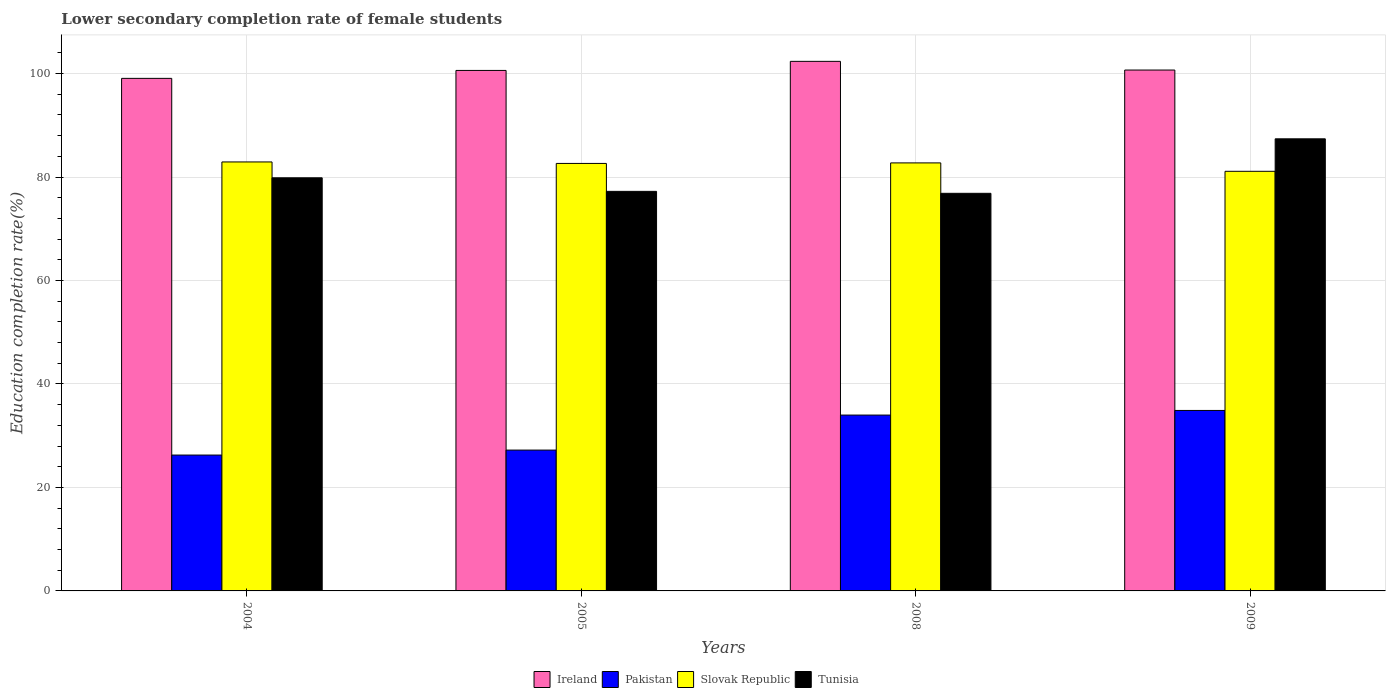How many groups of bars are there?
Offer a terse response. 4. Are the number of bars on each tick of the X-axis equal?
Provide a succinct answer. Yes. How many bars are there on the 1st tick from the left?
Offer a very short reply. 4. What is the lower secondary completion rate of female students in Slovak Republic in 2004?
Offer a very short reply. 82.92. Across all years, what is the maximum lower secondary completion rate of female students in Pakistan?
Ensure brevity in your answer.  34.88. Across all years, what is the minimum lower secondary completion rate of female students in Ireland?
Keep it short and to the point. 99.07. What is the total lower secondary completion rate of female students in Ireland in the graph?
Ensure brevity in your answer.  402.71. What is the difference between the lower secondary completion rate of female students in Ireland in 2005 and that in 2008?
Give a very brief answer. -1.76. What is the difference between the lower secondary completion rate of female students in Tunisia in 2005 and the lower secondary completion rate of female students in Ireland in 2004?
Provide a succinct answer. -21.84. What is the average lower secondary completion rate of female students in Slovak Republic per year?
Provide a succinct answer. 82.35. In the year 2004, what is the difference between the lower secondary completion rate of female students in Slovak Republic and lower secondary completion rate of female students in Pakistan?
Your answer should be compact. 56.66. What is the ratio of the lower secondary completion rate of female students in Ireland in 2005 to that in 2008?
Provide a short and direct response. 0.98. Is the lower secondary completion rate of female students in Slovak Republic in 2004 less than that in 2005?
Provide a short and direct response. No. What is the difference between the highest and the second highest lower secondary completion rate of female students in Ireland?
Provide a short and direct response. 1.68. What is the difference between the highest and the lowest lower secondary completion rate of female students in Slovak Republic?
Your answer should be very brief. 1.81. In how many years, is the lower secondary completion rate of female students in Ireland greater than the average lower secondary completion rate of female students in Ireland taken over all years?
Provide a succinct answer. 2. Is it the case that in every year, the sum of the lower secondary completion rate of female students in Slovak Republic and lower secondary completion rate of female students in Ireland is greater than the sum of lower secondary completion rate of female students in Pakistan and lower secondary completion rate of female students in Tunisia?
Make the answer very short. Yes. What does the 4th bar from the left in 2009 represents?
Your answer should be compact. Tunisia. What does the 2nd bar from the right in 2008 represents?
Give a very brief answer. Slovak Republic. How many bars are there?
Provide a succinct answer. 16. How many years are there in the graph?
Provide a succinct answer. 4. What is the difference between two consecutive major ticks on the Y-axis?
Offer a terse response. 20. Does the graph contain any zero values?
Your response must be concise. No. Does the graph contain grids?
Provide a short and direct response. Yes. How many legend labels are there?
Your answer should be very brief. 4. How are the legend labels stacked?
Your answer should be very brief. Horizontal. What is the title of the graph?
Make the answer very short. Lower secondary completion rate of female students. What is the label or title of the Y-axis?
Offer a terse response. Education completion rate(%). What is the Education completion rate(%) of Ireland in 2004?
Your response must be concise. 99.07. What is the Education completion rate(%) of Pakistan in 2004?
Give a very brief answer. 26.26. What is the Education completion rate(%) in Slovak Republic in 2004?
Provide a short and direct response. 82.92. What is the Education completion rate(%) in Tunisia in 2004?
Offer a terse response. 79.85. What is the Education completion rate(%) in Ireland in 2005?
Provide a short and direct response. 100.6. What is the Education completion rate(%) of Pakistan in 2005?
Keep it short and to the point. 27.22. What is the Education completion rate(%) in Slovak Republic in 2005?
Provide a short and direct response. 82.63. What is the Education completion rate(%) in Tunisia in 2005?
Make the answer very short. 77.23. What is the Education completion rate(%) in Ireland in 2008?
Your response must be concise. 102.36. What is the Education completion rate(%) of Pakistan in 2008?
Provide a succinct answer. 33.99. What is the Education completion rate(%) in Slovak Republic in 2008?
Your answer should be compact. 82.73. What is the Education completion rate(%) in Tunisia in 2008?
Your response must be concise. 76.85. What is the Education completion rate(%) of Ireland in 2009?
Offer a very short reply. 100.68. What is the Education completion rate(%) of Pakistan in 2009?
Offer a very short reply. 34.88. What is the Education completion rate(%) of Slovak Republic in 2009?
Give a very brief answer. 81.11. What is the Education completion rate(%) of Tunisia in 2009?
Give a very brief answer. 87.39. Across all years, what is the maximum Education completion rate(%) in Ireland?
Make the answer very short. 102.36. Across all years, what is the maximum Education completion rate(%) in Pakistan?
Offer a terse response. 34.88. Across all years, what is the maximum Education completion rate(%) of Slovak Republic?
Provide a short and direct response. 82.92. Across all years, what is the maximum Education completion rate(%) in Tunisia?
Make the answer very short. 87.39. Across all years, what is the minimum Education completion rate(%) in Ireland?
Offer a very short reply. 99.07. Across all years, what is the minimum Education completion rate(%) of Pakistan?
Give a very brief answer. 26.26. Across all years, what is the minimum Education completion rate(%) in Slovak Republic?
Keep it short and to the point. 81.11. Across all years, what is the minimum Education completion rate(%) of Tunisia?
Offer a terse response. 76.85. What is the total Education completion rate(%) in Ireland in the graph?
Give a very brief answer. 402.71. What is the total Education completion rate(%) of Pakistan in the graph?
Provide a short and direct response. 122.35. What is the total Education completion rate(%) of Slovak Republic in the graph?
Your answer should be very brief. 329.38. What is the total Education completion rate(%) in Tunisia in the graph?
Offer a terse response. 321.32. What is the difference between the Education completion rate(%) in Ireland in 2004 and that in 2005?
Make the answer very short. -1.53. What is the difference between the Education completion rate(%) of Pakistan in 2004 and that in 2005?
Provide a short and direct response. -0.96. What is the difference between the Education completion rate(%) of Slovak Republic in 2004 and that in 2005?
Offer a terse response. 0.29. What is the difference between the Education completion rate(%) in Tunisia in 2004 and that in 2005?
Your response must be concise. 2.62. What is the difference between the Education completion rate(%) in Ireland in 2004 and that in 2008?
Your answer should be compact. -3.29. What is the difference between the Education completion rate(%) in Pakistan in 2004 and that in 2008?
Offer a very short reply. -7.73. What is the difference between the Education completion rate(%) of Slovak Republic in 2004 and that in 2008?
Provide a short and direct response. 0.19. What is the difference between the Education completion rate(%) of Tunisia in 2004 and that in 2008?
Make the answer very short. 3. What is the difference between the Education completion rate(%) of Ireland in 2004 and that in 2009?
Provide a succinct answer. -1.61. What is the difference between the Education completion rate(%) of Pakistan in 2004 and that in 2009?
Your response must be concise. -8.62. What is the difference between the Education completion rate(%) of Slovak Republic in 2004 and that in 2009?
Offer a very short reply. 1.81. What is the difference between the Education completion rate(%) of Tunisia in 2004 and that in 2009?
Your response must be concise. -7.54. What is the difference between the Education completion rate(%) in Ireland in 2005 and that in 2008?
Offer a terse response. -1.76. What is the difference between the Education completion rate(%) of Pakistan in 2005 and that in 2008?
Provide a short and direct response. -6.77. What is the difference between the Education completion rate(%) in Slovak Republic in 2005 and that in 2008?
Provide a succinct answer. -0.1. What is the difference between the Education completion rate(%) of Tunisia in 2005 and that in 2008?
Offer a very short reply. 0.38. What is the difference between the Education completion rate(%) in Ireland in 2005 and that in 2009?
Your response must be concise. -0.08. What is the difference between the Education completion rate(%) of Pakistan in 2005 and that in 2009?
Keep it short and to the point. -7.66. What is the difference between the Education completion rate(%) in Slovak Republic in 2005 and that in 2009?
Provide a short and direct response. 1.52. What is the difference between the Education completion rate(%) in Tunisia in 2005 and that in 2009?
Give a very brief answer. -10.16. What is the difference between the Education completion rate(%) of Ireland in 2008 and that in 2009?
Give a very brief answer. 1.68. What is the difference between the Education completion rate(%) in Pakistan in 2008 and that in 2009?
Your response must be concise. -0.9. What is the difference between the Education completion rate(%) of Slovak Republic in 2008 and that in 2009?
Offer a terse response. 1.62. What is the difference between the Education completion rate(%) of Tunisia in 2008 and that in 2009?
Provide a succinct answer. -10.53. What is the difference between the Education completion rate(%) of Ireland in 2004 and the Education completion rate(%) of Pakistan in 2005?
Keep it short and to the point. 71.85. What is the difference between the Education completion rate(%) of Ireland in 2004 and the Education completion rate(%) of Slovak Republic in 2005?
Offer a terse response. 16.44. What is the difference between the Education completion rate(%) of Ireland in 2004 and the Education completion rate(%) of Tunisia in 2005?
Provide a succinct answer. 21.84. What is the difference between the Education completion rate(%) of Pakistan in 2004 and the Education completion rate(%) of Slovak Republic in 2005?
Ensure brevity in your answer.  -56.37. What is the difference between the Education completion rate(%) of Pakistan in 2004 and the Education completion rate(%) of Tunisia in 2005?
Offer a very short reply. -50.97. What is the difference between the Education completion rate(%) in Slovak Republic in 2004 and the Education completion rate(%) in Tunisia in 2005?
Your answer should be compact. 5.69. What is the difference between the Education completion rate(%) of Ireland in 2004 and the Education completion rate(%) of Pakistan in 2008?
Keep it short and to the point. 65.08. What is the difference between the Education completion rate(%) of Ireland in 2004 and the Education completion rate(%) of Slovak Republic in 2008?
Provide a short and direct response. 16.34. What is the difference between the Education completion rate(%) of Ireland in 2004 and the Education completion rate(%) of Tunisia in 2008?
Offer a terse response. 22.22. What is the difference between the Education completion rate(%) in Pakistan in 2004 and the Education completion rate(%) in Slovak Republic in 2008?
Offer a very short reply. -56.47. What is the difference between the Education completion rate(%) in Pakistan in 2004 and the Education completion rate(%) in Tunisia in 2008?
Provide a succinct answer. -50.59. What is the difference between the Education completion rate(%) of Slovak Republic in 2004 and the Education completion rate(%) of Tunisia in 2008?
Make the answer very short. 6.06. What is the difference between the Education completion rate(%) in Ireland in 2004 and the Education completion rate(%) in Pakistan in 2009?
Keep it short and to the point. 64.19. What is the difference between the Education completion rate(%) of Ireland in 2004 and the Education completion rate(%) of Slovak Republic in 2009?
Provide a succinct answer. 17.96. What is the difference between the Education completion rate(%) in Ireland in 2004 and the Education completion rate(%) in Tunisia in 2009?
Keep it short and to the point. 11.69. What is the difference between the Education completion rate(%) in Pakistan in 2004 and the Education completion rate(%) in Slovak Republic in 2009?
Make the answer very short. -54.85. What is the difference between the Education completion rate(%) in Pakistan in 2004 and the Education completion rate(%) in Tunisia in 2009?
Offer a terse response. -61.13. What is the difference between the Education completion rate(%) of Slovak Republic in 2004 and the Education completion rate(%) of Tunisia in 2009?
Ensure brevity in your answer.  -4.47. What is the difference between the Education completion rate(%) of Ireland in 2005 and the Education completion rate(%) of Pakistan in 2008?
Give a very brief answer. 66.61. What is the difference between the Education completion rate(%) of Ireland in 2005 and the Education completion rate(%) of Slovak Republic in 2008?
Keep it short and to the point. 17.87. What is the difference between the Education completion rate(%) in Ireland in 2005 and the Education completion rate(%) in Tunisia in 2008?
Make the answer very short. 23.75. What is the difference between the Education completion rate(%) in Pakistan in 2005 and the Education completion rate(%) in Slovak Republic in 2008?
Provide a short and direct response. -55.51. What is the difference between the Education completion rate(%) of Pakistan in 2005 and the Education completion rate(%) of Tunisia in 2008?
Ensure brevity in your answer.  -49.63. What is the difference between the Education completion rate(%) in Slovak Republic in 2005 and the Education completion rate(%) in Tunisia in 2008?
Provide a succinct answer. 5.78. What is the difference between the Education completion rate(%) in Ireland in 2005 and the Education completion rate(%) in Pakistan in 2009?
Your answer should be compact. 65.72. What is the difference between the Education completion rate(%) of Ireland in 2005 and the Education completion rate(%) of Slovak Republic in 2009?
Give a very brief answer. 19.5. What is the difference between the Education completion rate(%) of Ireland in 2005 and the Education completion rate(%) of Tunisia in 2009?
Your answer should be compact. 13.22. What is the difference between the Education completion rate(%) in Pakistan in 2005 and the Education completion rate(%) in Slovak Republic in 2009?
Your answer should be compact. -53.89. What is the difference between the Education completion rate(%) in Pakistan in 2005 and the Education completion rate(%) in Tunisia in 2009?
Offer a terse response. -60.16. What is the difference between the Education completion rate(%) in Slovak Republic in 2005 and the Education completion rate(%) in Tunisia in 2009?
Offer a very short reply. -4.76. What is the difference between the Education completion rate(%) of Ireland in 2008 and the Education completion rate(%) of Pakistan in 2009?
Make the answer very short. 67.47. What is the difference between the Education completion rate(%) of Ireland in 2008 and the Education completion rate(%) of Slovak Republic in 2009?
Offer a very short reply. 21.25. What is the difference between the Education completion rate(%) of Ireland in 2008 and the Education completion rate(%) of Tunisia in 2009?
Offer a terse response. 14.97. What is the difference between the Education completion rate(%) of Pakistan in 2008 and the Education completion rate(%) of Slovak Republic in 2009?
Give a very brief answer. -47.12. What is the difference between the Education completion rate(%) in Pakistan in 2008 and the Education completion rate(%) in Tunisia in 2009?
Keep it short and to the point. -53.4. What is the difference between the Education completion rate(%) in Slovak Republic in 2008 and the Education completion rate(%) in Tunisia in 2009?
Give a very brief answer. -4.66. What is the average Education completion rate(%) in Ireland per year?
Provide a succinct answer. 100.68. What is the average Education completion rate(%) of Pakistan per year?
Offer a terse response. 30.59. What is the average Education completion rate(%) of Slovak Republic per year?
Your answer should be compact. 82.35. What is the average Education completion rate(%) in Tunisia per year?
Offer a very short reply. 80.33. In the year 2004, what is the difference between the Education completion rate(%) of Ireland and Education completion rate(%) of Pakistan?
Provide a succinct answer. 72.81. In the year 2004, what is the difference between the Education completion rate(%) of Ireland and Education completion rate(%) of Slovak Republic?
Offer a very short reply. 16.16. In the year 2004, what is the difference between the Education completion rate(%) of Ireland and Education completion rate(%) of Tunisia?
Your answer should be compact. 19.22. In the year 2004, what is the difference between the Education completion rate(%) of Pakistan and Education completion rate(%) of Slovak Republic?
Make the answer very short. -56.66. In the year 2004, what is the difference between the Education completion rate(%) in Pakistan and Education completion rate(%) in Tunisia?
Your response must be concise. -53.59. In the year 2004, what is the difference between the Education completion rate(%) of Slovak Republic and Education completion rate(%) of Tunisia?
Offer a very short reply. 3.07. In the year 2005, what is the difference between the Education completion rate(%) of Ireland and Education completion rate(%) of Pakistan?
Keep it short and to the point. 73.38. In the year 2005, what is the difference between the Education completion rate(%) of Ireland and Education completion rate(%) of Slovak Republic?
Offer a terse response. 17.98. In the year 2005, what is the difference between the Education completion rate(%) in Ireland and Education completion rate(%) in Tunisia?
Your response must be concise. 23.37. In the year 2005, what is the difference between the Education completion rate(%) of Pakistan and Education completion rate(%) of Slovak Republic?
Keep it short and to the point. -55.41. In the year 2005, what is the difference between the Education completion rate(%) in Pakistan and Education completion rate(%) in Tunisia?
Your answer should be compact. -50.01. In the year 2005, what is the difference between the Education completion rate(%) in Slovak Republic and Education completion rate(%) in Tunisia?
Offer a very short reply. 5.4. In the year 2008, what is the difference between the Education completion rate(%) of Ireland and Education completion rate(%) of Pakistan?
Your response must be concise. 68.37. In the year 2008, what is the difference between the Education completion rate(%) in Ireland and Education completion rate(%) in Slovak Republic?
Offer a terse response. 19.63. In the year 2008, what is the difference between the Education completion rate(%) in Ireland and Education completion rate(%) in Tunisia?
Offer a terse response. 25.51. In the year 2008, what is the difference between the Education completion rate(%) in Pakistan and Education completion rate(%) in Slovak Republic?
Give a very brief answer. -48.74. In the year 2008, what is the difference between the Education completion rate(%) in Pakistan and Education completion rate(%) in Tunisia?
Offer a very short reply. -42.86. In the year 2008, what is the difference between the Education completion rate(%) in Slovak Republic and Education completion rate(%) in Tunisia?
Keep it short and to the point. 5.88. In the year 2009, what is the difference between the Education completion rate(%) of Ireland and Education completion rate(%) of Pakistan?
Offer a terse response. 65.8. In the year 2009, what is the difference between the Education completion rate(%) of Ireland and Education completion rate(%) of Slovak Republic?
Offer a very short reply. 19.57. In the year 2009, what is the difference between the Education completion rate(%) of Ireland and Education completion rate(%) of Tunisia?
Provide a succinct answer. 13.29. In the year 2009, what is the difference between the Education completion rate(%) of Pakistan and Education completion rate(%) of Slovak Republic?
Offer a terse response. -46.22. In the year 2009, what is the difference between the Education completion rate(%) of Pakistan and Education completion rate(%) of Tunisia?
Give a very brief answer. -52.5. In the year 2009, what is the difference between the Education completion rate(%) of Slovak Republic and Education completion rate(%) of Tunisia?
Offer a very short reply. -6.28. What is the ratio of the Education completion rate(%) of Ireland in 2004 to that in 2005?
Ensure brevity in your answer.  0.98. What is the ratio of the Education completion rate(%) in Pakistan in 2004 to that in 2005?
Keep it short and to the point. 0.96. What is the ratio of the Education completion rate(%) in Slovak Republic in 2004 to that in 2005?
Provide a succinct answer. 1. What is the ratio of the Education completion rate(%) in Tunisia in 2004 to that in 2005?
Make the answer very short. 1.03. What is the ratio of the Education completion rate(%) of Ireland in 2004 to that in 2008?
Give a very brief answer. 0.97. What is the ratio of the Education completion rate(%) of Pakistan in 2004 to that in 2008?
Offer a very short reply. 0.77. What is the ratio of the Education completion rate(%) of Tunisia in 2004 to that in 2008?
Keep it short and to the point. 1.04. What is the ratio of the Education completion rate(%) of Pakistan in 2004 to that in 2009?
Give a very brief answer. 0.75. What is the ratio of the Education completion rate(%) in Slovak Republic in 2004 to that in 2009?
Provide a short and direct response. 1.02. What is the ratio of the Education completion rate(%) in Tunisia in 2004 to that in 2009?
Your answer should be compact. 0.91. What is the ratio of the Education completion rate(%) of Ireland in 2005 to that in 2008?
Give a very brief answer. 0.98. What is the ratio of the Education completion rate(%) in Pakistan in 2005 to that in 2008?
Provide a short and direct response. 0.8. What is the ratio of the Education completion rate(%) of Slovak Republic in 2005 to that in 2008?
Your answer should be very brief. 1. What is the ratio of the Education completion rate(%) of Tunisia in 2005 to that in 2008?
Provide a short and direct response. 1. What is the ratio of the Education completion rate(%) of Ireland in 2005 to that in 2009?
Provide a succinct answer. 1. What is the ratio of the Education completion rate(%) of Pakistan in 2005 to that in 2009?
Give a very brief answer. 0.78. What is the ratio of the Education completion rate(%) in Slovak Republic in 2005 to that in 2009?
Your response must be concise. 1.02. What is the ratio of the Education completion rate(%) in Tunisia in 2005 to that in 2009?
Ensure brevity in your answer.  0.88. What is the ratio of the Education completion rate(%) of Ireland in 2008 to that in 2009?
Offer a very short reply. 1.02. What is the ratio of the Education completion rate(%) of Pakistan in 2008 to that in 2009?
Offer a very short reply. 0.97. What is the ratio of the Education completion rate(%) in Tunisia in 2008 to that in 2009?
Ensure brevity in your answer.  0.88. What is the difference between the highest and the second highest Education completion rate(%) in Ireland?
Provide a short and direct response. 1.68. What is the difference between the highest and the second highest Education completion rate(%) in Pakistan?
Keep it short and to the point. 0.9. What is the difference between the highest and the second highest Education completion rate(%) in Slovak Republic?
Ensure brevity in your answer.  0.19. What is the difference between the highest and the second highest Education completion rate(%) in Tunisia?
Ensure brevity in your answer.  7.54. What is the difference between the highest and the lowest Education completion rate(%) of Ireland?
Keep it short and to the point. 3.29. What is the difference between the highest and the lowest Education completion rate(%) of Pakistan?
Your response must be concise. 8.62. What is the difference between the highest and the lowest Education completion rate(%) of Slovak Republic?
Your answer should be very brief. 1.81. What is the difference between the highest and the lowest Education completion rate(%) of Tunisia?
Your answer should be compact. 10.53. 